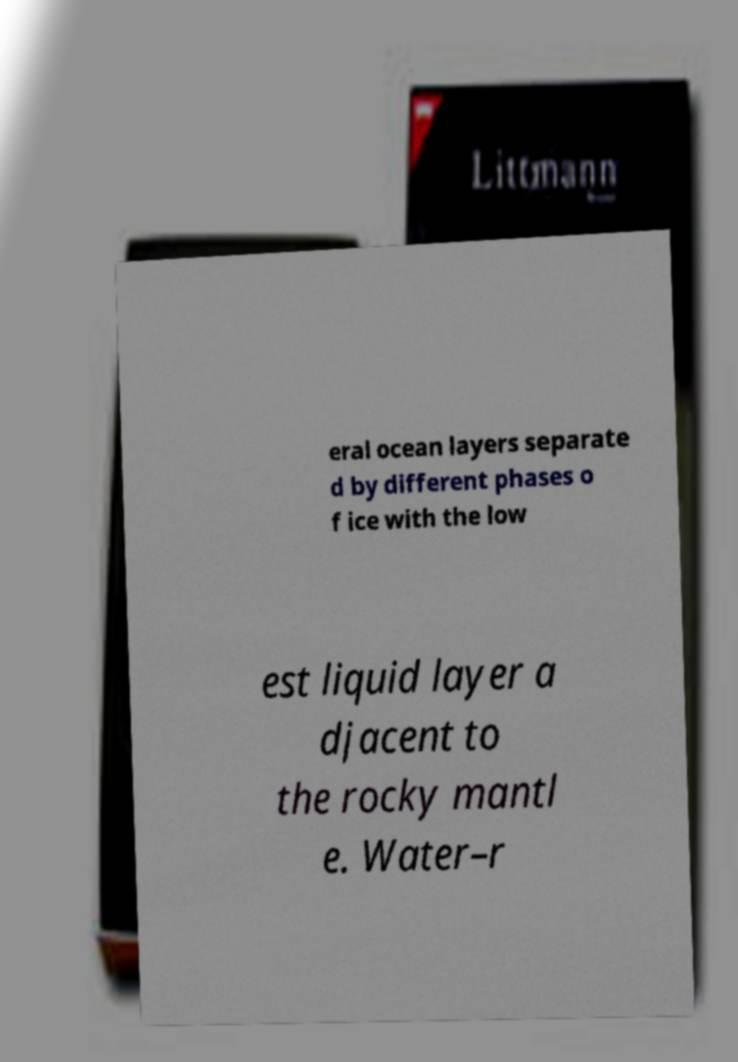Could you extract and type out the text from this image? eral ocean layers separate d by different phases o f ice with the low est liquid layer a djacent to the rocky mantl e. Water–r 